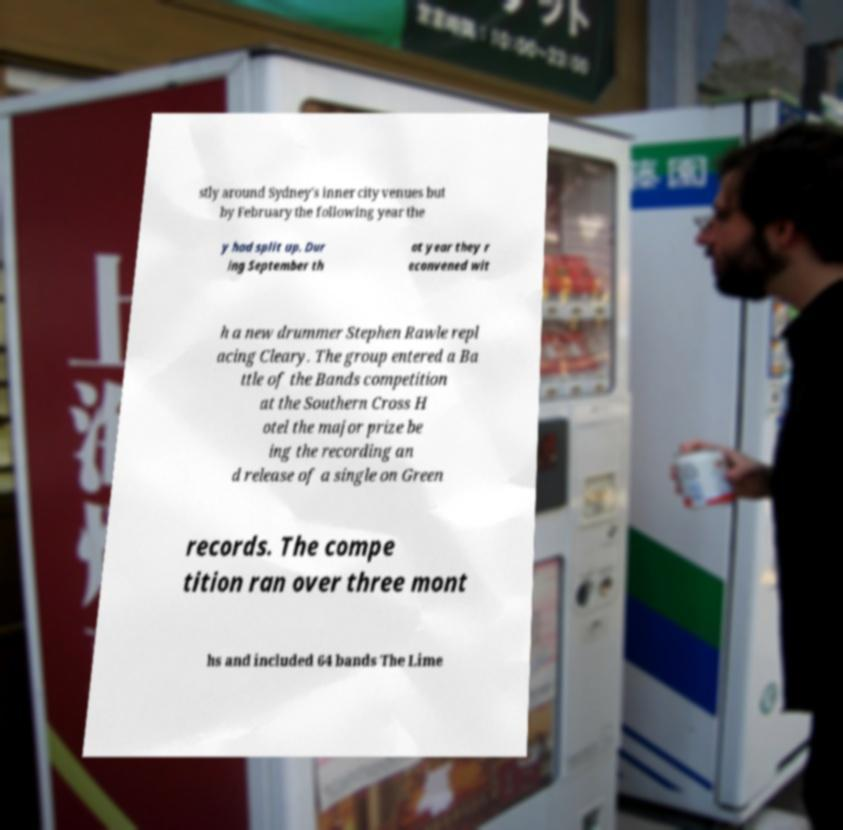Please read and relay the text visible in this image. What does it say? stly around Sydney's inner city venues but by February the following year the y had split up. Dur ing September th at year they r econvened wit h a new drummer Stephen Rawle repl acing Cleary. The group entered a Ba ttle of the Bands competition at the Southern Cross H otel the major prize be ing the recording an d release of a single on Green records. The compe tition ran over three mont hs and included 64 bands The Lime 